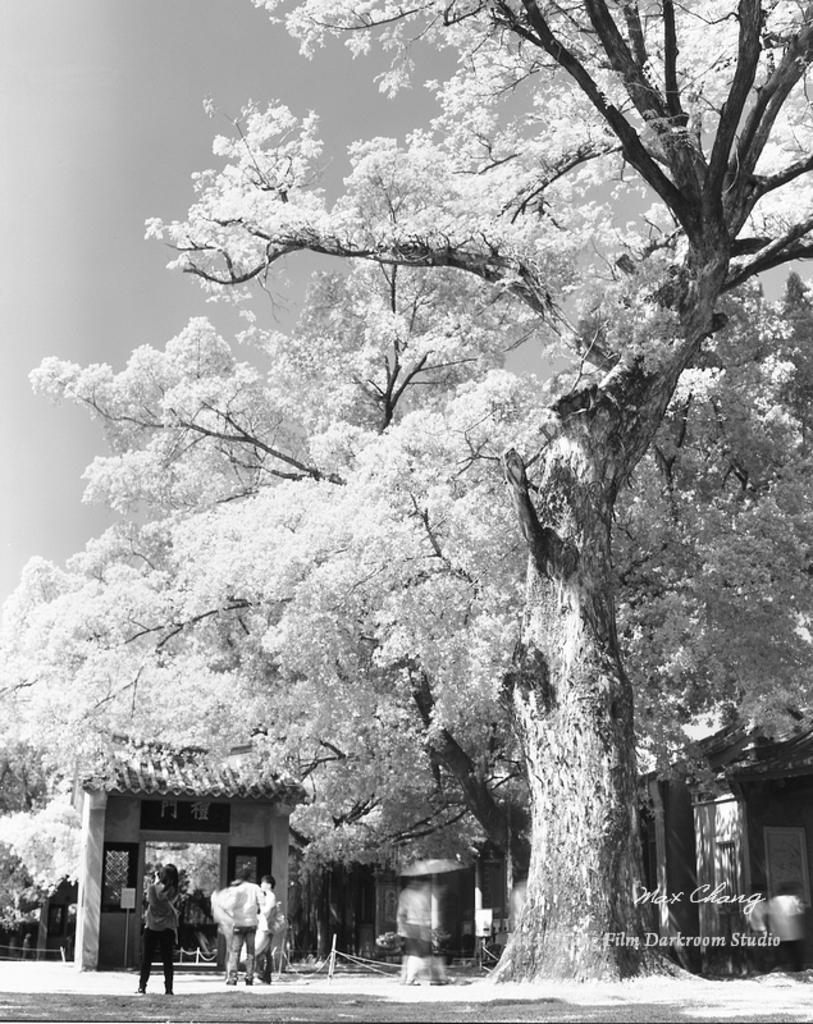Could you give a brief overview of what you see in this image? This is a black and white image. In this image there are trees. Also there is a building. And there are few people. In the background there is sky. In the right bottom corner there is watermark. 